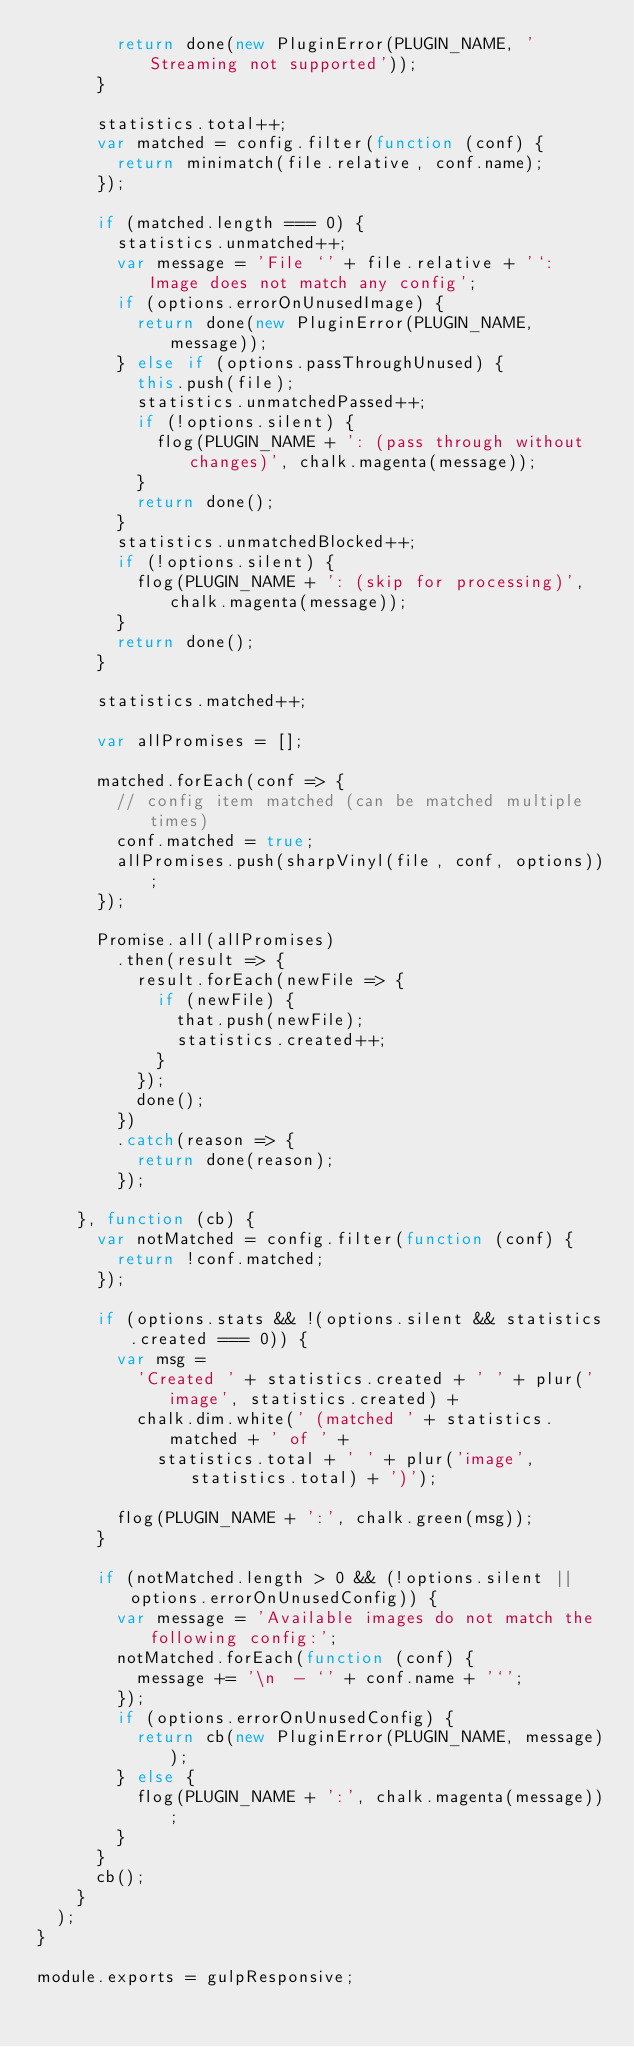<code> <loc_0><loc_0><loc_500><loc_500><_JavaScript_>        return done(new PluginError(PLUGIN_NAME, 'Streaming not supported'));
      }

      statistics.total++;
      var matched = config.filter(function (conf) {
        return minimatch(file.relative, conf.name);
      });

      if (matched.length === 0) {
        statistics.unmatched++;
        var message = 'File `' + file.relative + '`: Image does not match any config';
        if (options.errorOnUnusedImage) {
          return done(new PluginError(PLUGIN_NAME, message));
        } else if (options.passThroughUnused) {
          this.push(file);
          statistics.unmatchedPassed++;
          if (!options.silent) {
            flog(PLUGIN_NAME + ': (pass through without changes)', chalk.magenta(message));
          }
          return done();
        }
        statistics.unmatchedBlocked++;
        if (!options.silent) {
          flog(PLUGIN_NAME + ': (skip for processing)', chalk.magenta(message));
        }
        return done();
      }

      statistics.matched++;

      var allPromises = [];

      matched.forEach(conf => {
        // config item matched (can be matched multiple times)
        conf.matched = true;
        allPromises.push(sharpVinyl(file, conf, options));
      });

      Promise.all(allPromises)
        .then(result => {
          result.forEach(newFile => {
            if (newFile) {
              that.push(newFile);
              statistics.created++;
            }
          });
          done();
        })
        .catch(reason => {
          return done(reason);
        });

    }, function (cb) {
      var notMatched = config.filter(function (conf) {
        return !conf.matched;
      });

      if (options.stats && !(options.silent && statistics.created === 0)) {
        var msg =
          'Created ' + statistics.created + ' ' + plur('image', statistics.created) +
          chalk.dim.white(' (matched ' + statistics.matched + ' of ' +
            statistics.total + ' ' + plur('image', statistics.total) + ')');

        flog(PLUGIN_NAME + ':', chalk.green(msg));
      }

      if (notMatched.length > 0 && (!options.silent || options.errorOnUnusedConfig)) {
        var message = 'Available images do not match the following config:';
        notMatched.forEach(function (conf) {
          message += '\n  - `' + conf.name + '`';
        });
        if (options.errorOnUnusedConfig) {
          return cb(new PluginError(PLUGIN_NAME, message));
        } else {
          flog(PLUGIN_NAME + ':', chalk.magenta(message));
        }
      }
      cb();
    }
  );
}

module.exports = gulpResponsive;
</code> 